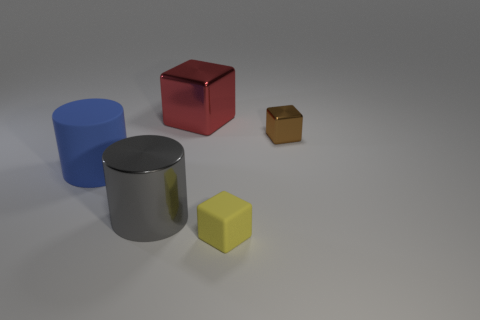Subtract all cubes. How many objects are left? 2 Subtract all red cubes. How many cubes are left? 2 Subtract all yellow cubes. How many cubes are left? 2 Subtract 0 brown cylinders. How many objects are left? 5 Subtract all yellow blocks. Subtract all red cylinders. How many blocks are left? 2 Subtract all brown cylinders. How many blue cubes are left? 0 Subtract all red blocks. Subtract all big green matte spheres. How many objects are left? 4 Add 4 brown shiny objects. How many brown shiny objects are left? 5 Add 4 big objects. How many big objects exist? 7 Add 2 blue cylinders. How many objects exist? 7 